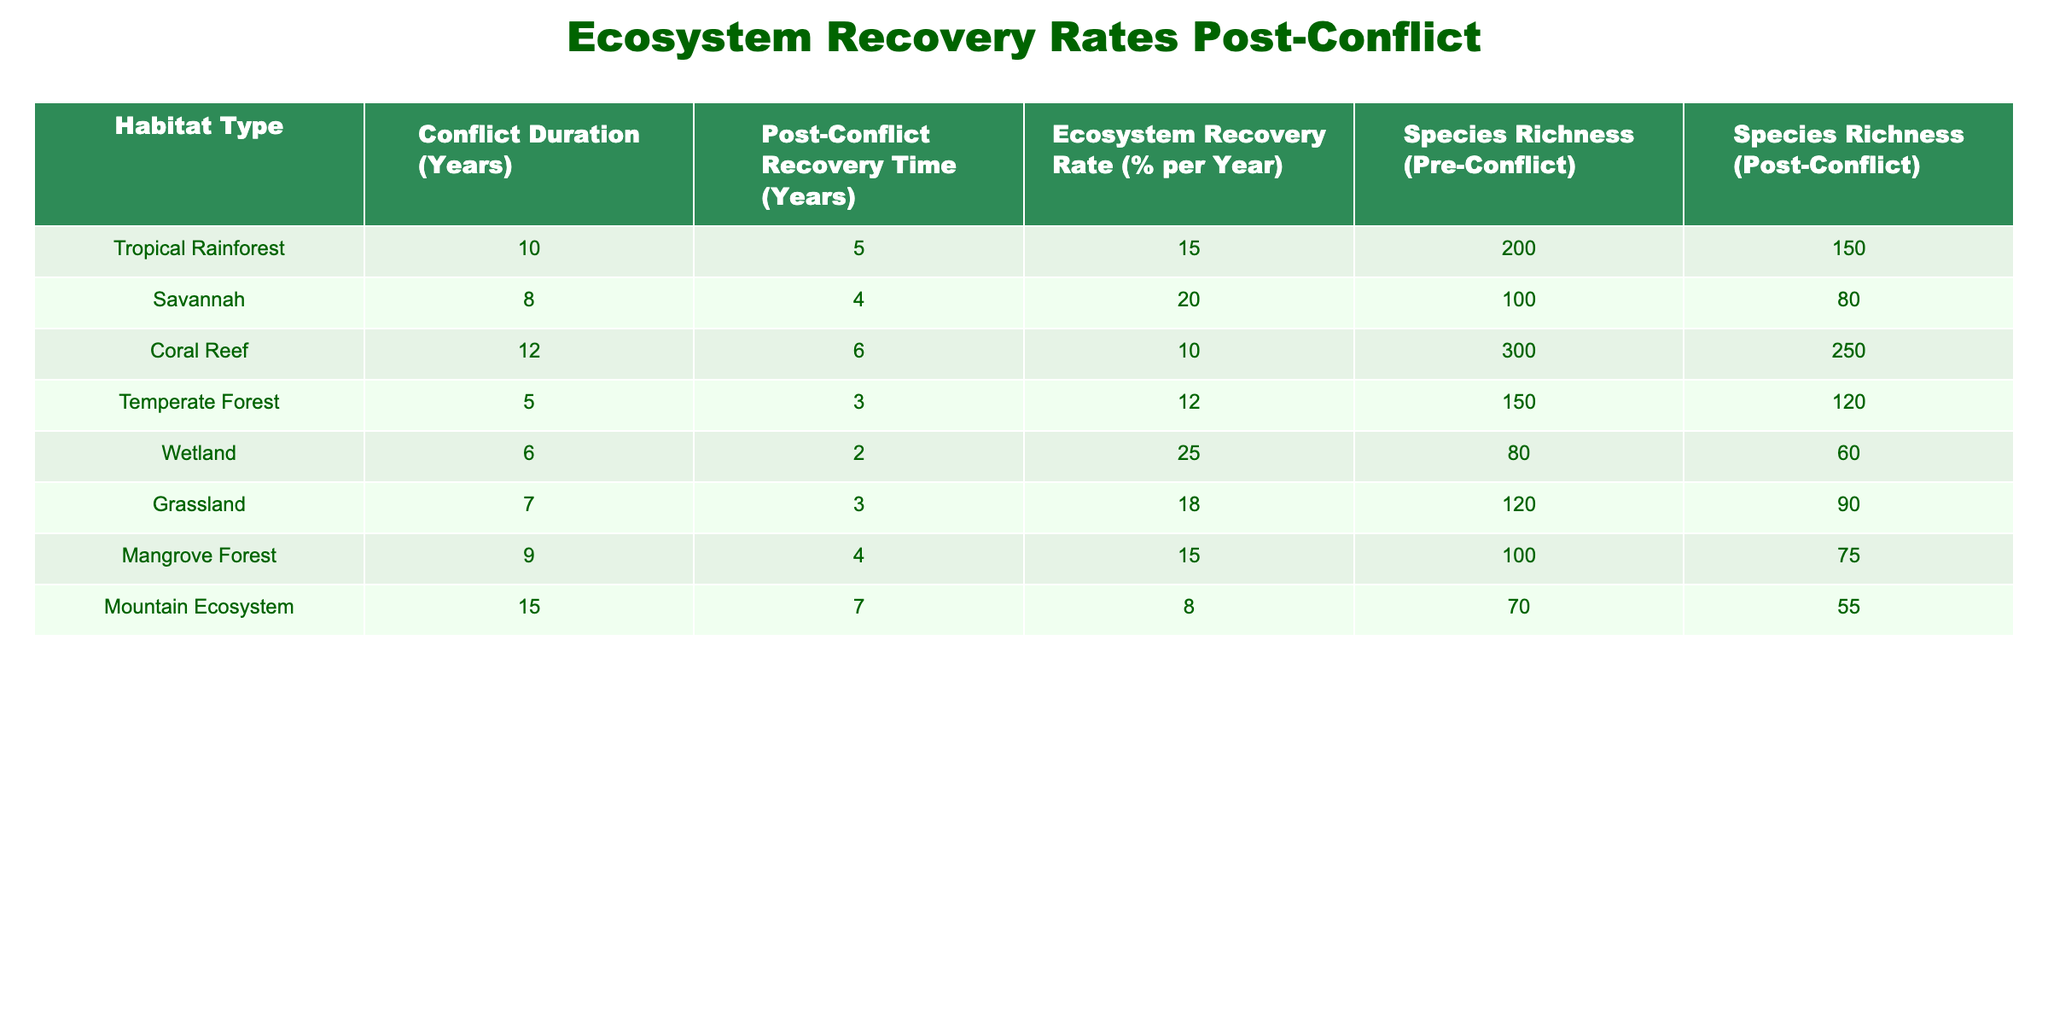What is the ecosystem recovery rate for Wetlands? The table shows the ecosystem recovery rate for Wetlands in the column labeled "Ecosystem Recovery Rate (% per Year)". The value provided is 25%.
Answer: 25% What was the species richness in Tropical Rainforests before the conflict? Looking at the column "Species Richness (Pre-Conflict)" for Tropical Rainforest, the value is 200.
Answer: 200 Is the post-conflict recovery time for Grasslands longer than that for Coral Reefs? By comparing the "Post-Conflict Recovery Time (Years)" for Grassland, which is 3 years, with that for Coral Reef, which is 6 years, we see that Grassland's recovery time is shorter.
Answer: No What is the average ecosystem recovery rate across all habitats listed? To find the average, sum the ecosystem recovery rates for all habitats (15 + 20 + 10 + 12 + 25 + 18 + 15 + 8) = 118. There are 8 habitats, so the average is 118/8 = 14.75%.
Answer: 14.75% Which habitat type experienced the longest conflict duration, and how many years did it last? The habitat type with the longest conflict duration is the Mountain Ecosystem with a conflict duration of 15 years according to the column labeled "Conflict Duration (Years)".
Answer: Mountain Ecosystem, 15 years What percentage of species richness was lost in Coral Reefs post-conflict? The species richness pre-conflict for Coral Reefs was 300 and post-conflict it is 250. The loss is 300 - 250 = 50. To find the percentage lost: (50 / 300) * 100 = 16.67%.
Answer: 16.67% Do Savannahs have a higher ecosystem recovery rate compared to Mangrove Forests? Comparing the ecosystem recovery rates, Savannahs are at 20% while Mangrove Forests are at 15%. Since 20% is greater than 15%, Savannahs do have a higher recovery rate.
Answer: Yes What is the difference in post-conflict recovery time between Temperate Forests and Wetlands? Temperate Forests have a post-conflict recovery time of 3 years, while Wetlands have a recovery time of 2 years. The difference is 3 - 2 = 1 year.
Answer: 1 year 